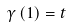Convert formula to latex. <formula><loc_0><loc_0><loc_500><loc_500>\gamma \left ( 1 \right ) = t</formula> 